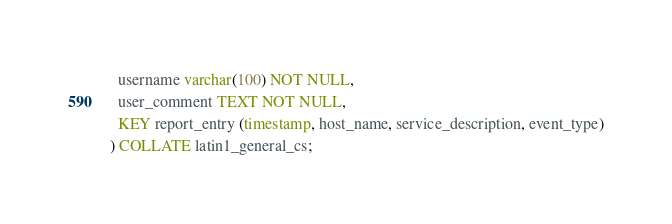Convert code to text. <code><loc_0><loc_0><loc_500><loc_500><_SQL_>  username varchar(100) NOT NULL,
  user_comment TEXT NOT NULL,
  KEY report_entry (timestamp, host_name, service_description, event_type)
) COLLATE latin1_general_cs;

</code> 